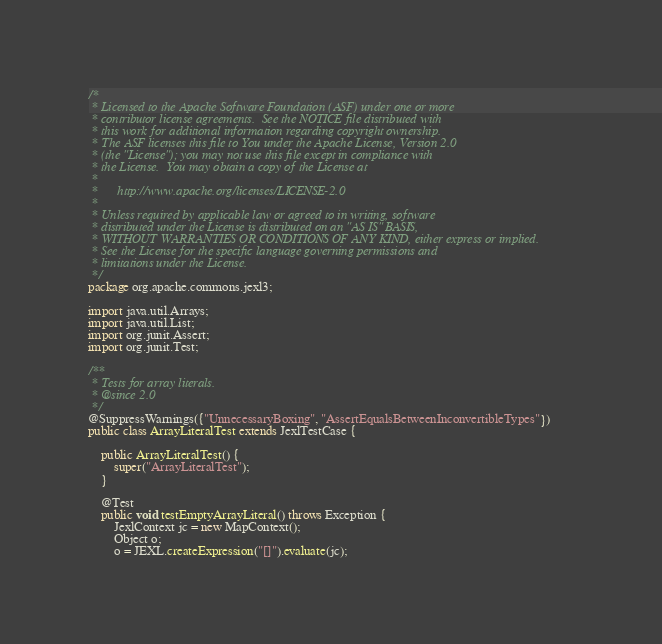<code> <loc_0><loc_0><loc_500><loc_500><_Java_>/*
 * Licensed to the Apache Software Foundation (ASF) under one or more
 * contributor license agreements.  See the NOTICE file distributed with
 * this work for additional information regarding copyright ownership.
 * The ASF licenses this file to You under the Apache License, Version 2.0
 * (the "License"); you may not use this file except in compliance with
 * the License.  You may obtain a copy of the License at
 *
 *      http://www.apache.org/licenses/LICENSE-2.0
 *
 * Unless required by applicable law or agreed to in writing, software
 * distributed under the License is distributed on an "AS IS" BASIS,
 * WITHOUT WARRANTIES OR CONDITIONS OF ANY KIND, either express or implied.
 * See the License for the specific language governing permissions and
 * limitations under the License.
 */
package org.apache.commons.jexl3;

import java.util.Arrays;
import java.util.List;
import org.junit.Assert;
import org.junit.Test;

/**
 * Tests for array literals.
 * @since 2.0
 */
@SuppressWarnings({"UnnecessaryBoxing", "AssertEqualsBetweenInconvertibleTypes"})
public class ArrayLiteralTest extends JexlTestCase {

    public ArrayLiteralTest() {
        super("ArrayLiteralTest");
    }

    @Test
    public void testEmptyArrayLiteral() throws Exception {
        JexlContext jc = new MapContext();
        Object o;
        o = JEXL.createExpression("[]").evaluate(jc);</code> 